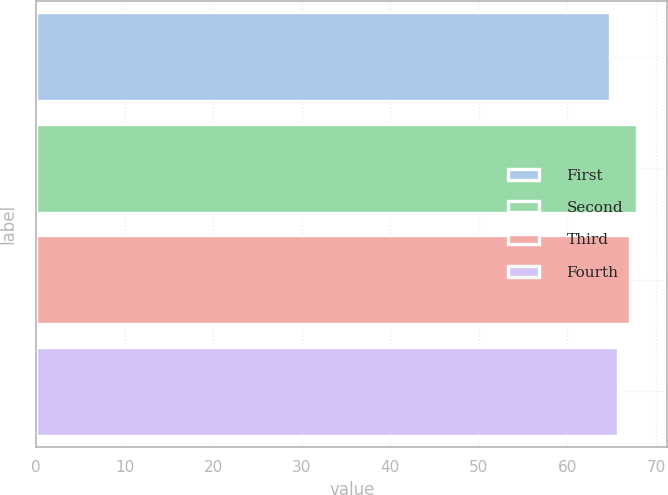Convert chart. <chart><loc_0><loc_0><loc_500><loc_500><bar_chart><fcel>First<fcel>Second<fcel>Third<fcel>Fourth<nl><fcel>64.79<fcel>67.89<fcel>67.04<fcel>65.73<nl></chart> 